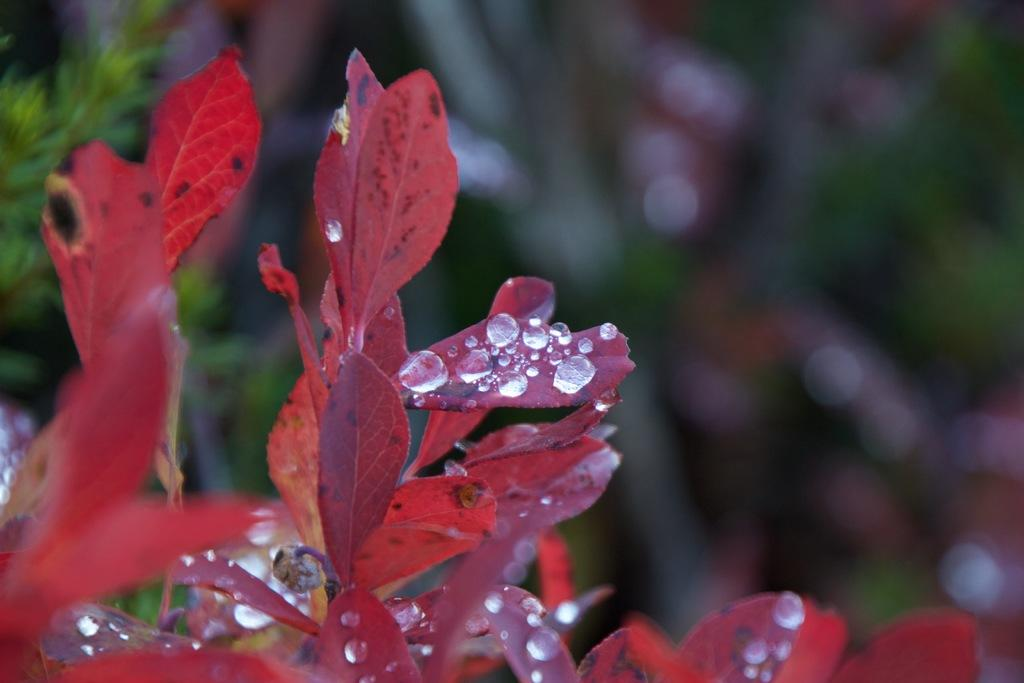What color is the plant in the image? The plant in the image is red. Where is the plant located in the image? The plant is on the left side of the image. What can be observed on the leaves of the plant? There are water drops on the leaves of the plant. How would you describe the background of the image? The background of the image is blurry. Can you see the tongue of the person who watered the plant in the image? There is no person or tongue visible in the image; it only features a red plant with water drops on its leaves and a blurry background. 